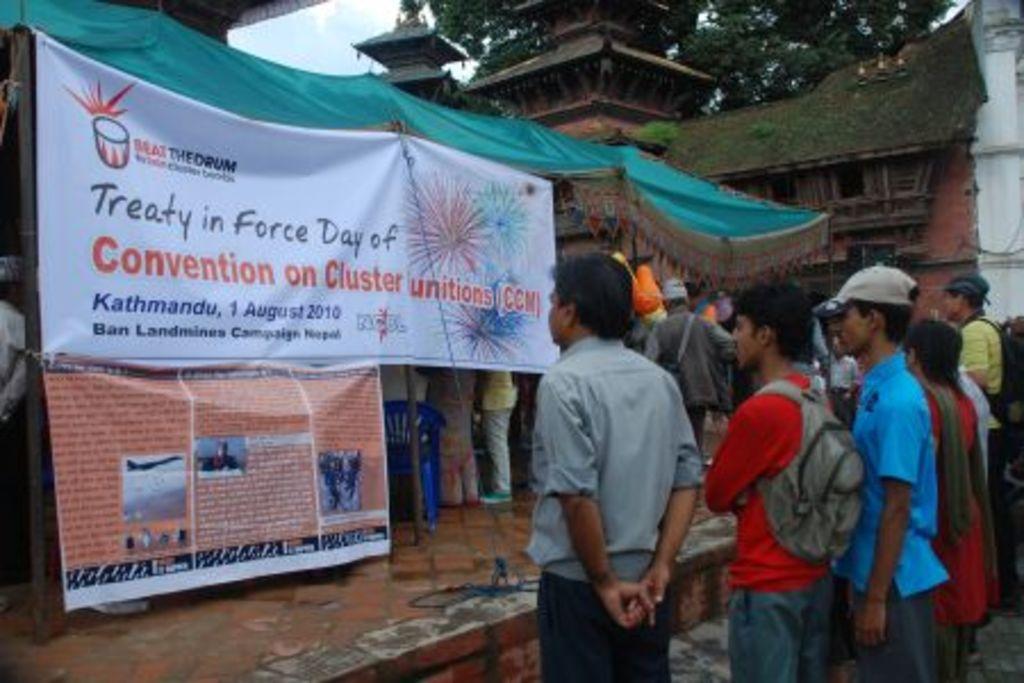In one or two sentences, can you explain what this image depicts? This image consists of many people standing on the road. In the front, there are tents along with banners. On the right, we can see a house along with windows. At the top, there are trees and sky. 